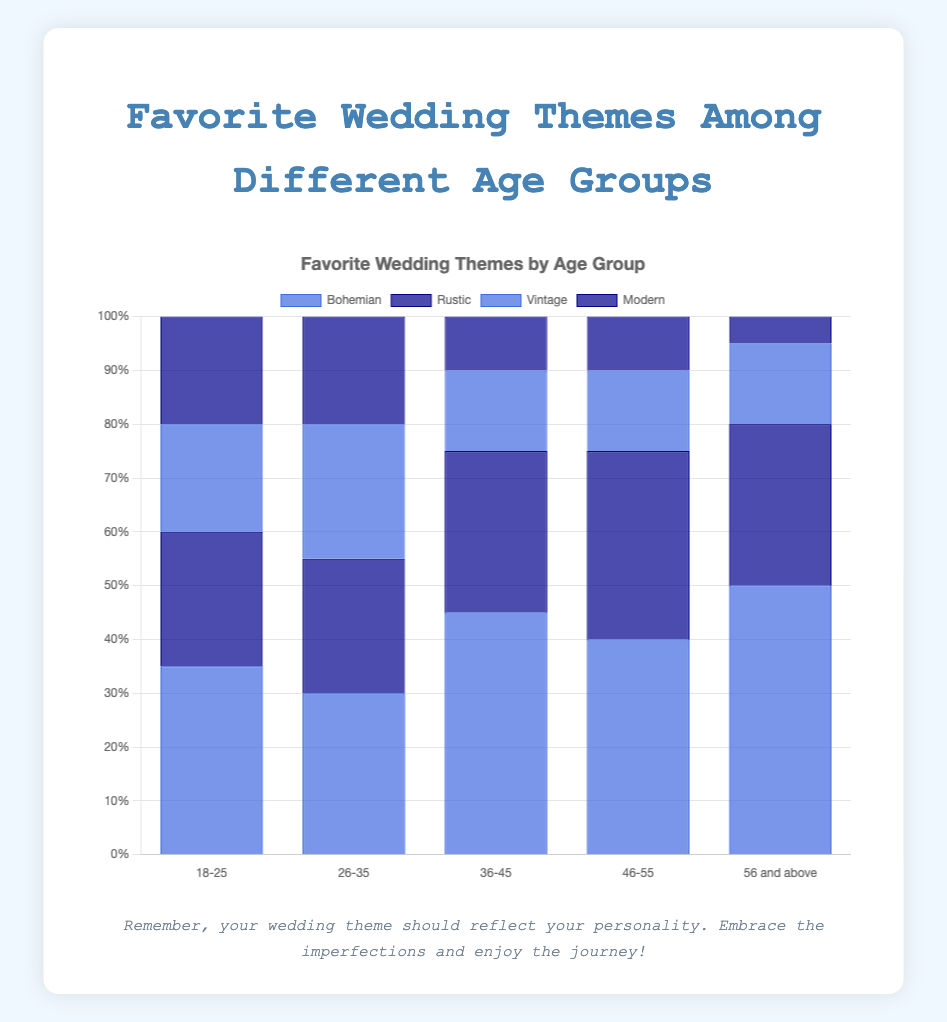Which age group prefers the "Bohemian" theme the most? The "Bohemian" theme is represented by a blue bar, and the percentage for each age group shows that the 18-25 age group has the highest percentage at 35%.
Answer: 18-25 What is the total percentage for the themes "Rustic" and "Modern" in the 18-25 age group? In the 18-25 age group, "Rustic" has a percentage of 25% and "Modern" has a percentage of 20%. Adding them together gives 25 + 20 = 45%.
Answer: 45% Which theme is most popular among the 56 and above age group? The classic theme has the highest percentage bar in the 56 and above age group at 50%.
Answer: Classic Compare the popularity of the "Beach" theme across all age groups. Which age group favors it the most? The "Beach" theme is found only in the 26-35 age group with a percentage of 20%, making this the age group that favors it the most.
Answer: 26-35 Which age group has the highest preference for the "Traditional" theme? The highest blue bar for the "Traditional" theme is found in the 36-45 age group at 45%.
Answer: 36-45 How does preference for the "Romantic" theme change with age? By observing the height of the dark blue bars labeled "Romantic", it's seen that the preference is 30% for 36-45, 35% for 46-55, and 15% for 56 and above. Thus, preference increases from 36-45 to 46-55 and decreases afterward.
Answer: Increases and then decreases What is the difference in percentage between the "Classic" theme in the 56 and above age group and the 26-35 age group? The "Classic" theme percentages are 50% for 56 and above and 30% for 26-35. The difference is 50 - 30 = 20%.
Answer: 20% If you add the preferences for the "Vintage" theme in the 18-25 and 36-45 age groups, what is the total percentage? The "Vintage" theme percentages are 20% for 18-25 and 15% for 36-45. Adding these gives 20 + 15 = 35%.
Answer: 35% Which age group shows the lowest combined preference for the "Garden" and "Glamorous" themes? Reviewing the blue and dark blue bars, only the 26-35 age group includes both of these themes with combined percentages of 25% for "Garden" and 25% for "Glamorous", totaling 50%. The other groups have either one or none, making 26-35 the lowest for both combined.
Answer: 26-35 